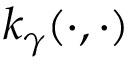<formula> <loc_0><loc_0><loc_500><loc_500>k _ { \gamma } ( \cdot , \cdot )</formula> 